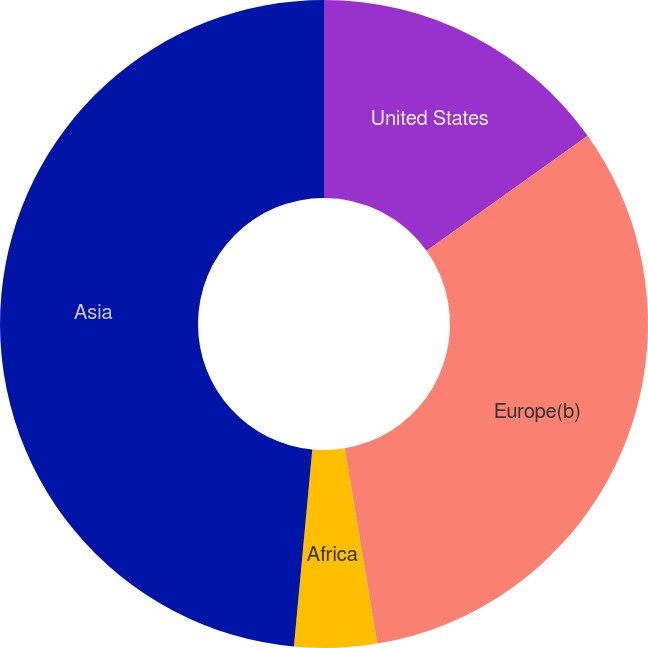Convert chart. <chart><loc_0><loc_0><loc_500><loc_500><pie_chart><fcel>United States<fcel>Europe(b)<fcel>Africa<fcel>Asia<nl><fcel>15.13%<fcel>32.24%<fcel>4.11%<fcel>48.52%<nl></chart> 